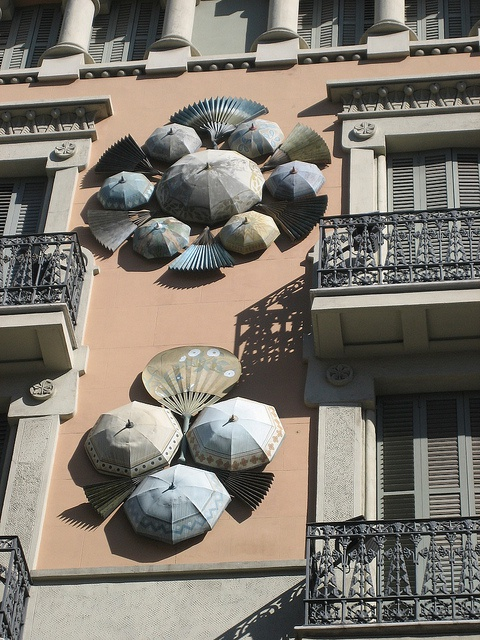Describe the objects in this image and their specific colors. I can see umbrella in black, darkgray, lightgray, and gray tones, umbrella in black, lightgray, darkgray, and gray tones, umbrella in black, lightgray, darkgray, and gray tones, umbrella in black, white, gray, darkgray, and lightgray tones, and umbrella in black, lightgray, darkgray, and gray tones in this image. 